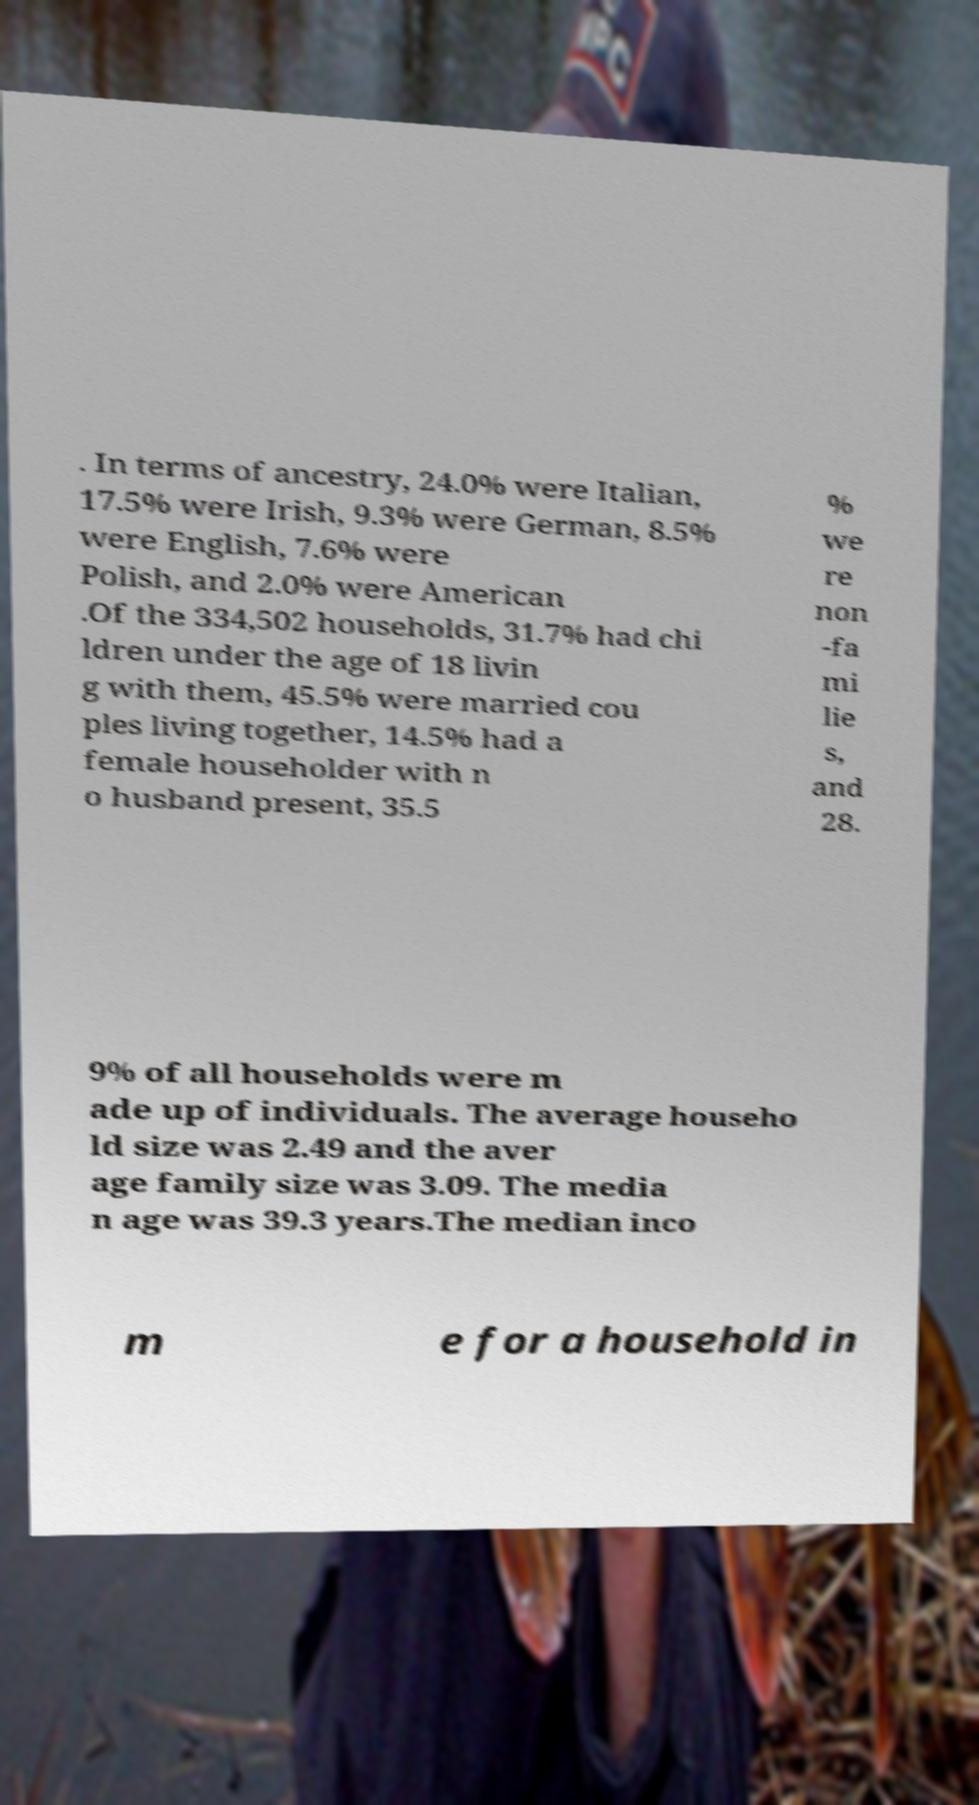For documentation purposes, I need the text within this image transcribed. Could you provide that? . In terms of ancestry, 24.0% were Italian, 17.5% were Irish, 9.3% were German, 8.5% were English, 7.6% were Polish, and 2.0% were American .Of the 334,502 households, 31.7% had chi ldren under the age of 18 livin g with them, 45.5% were married cou ples living together, 14.5% had a female householder with n o husband present, 35.5 % we re non -fa mi lie s, and 28. 9% of all households were m ade up of individuals. The average househo ld size was 2.49 and the aver age family size was 3.09. The media n age was 39.3 years.The median inco m e for a household in 